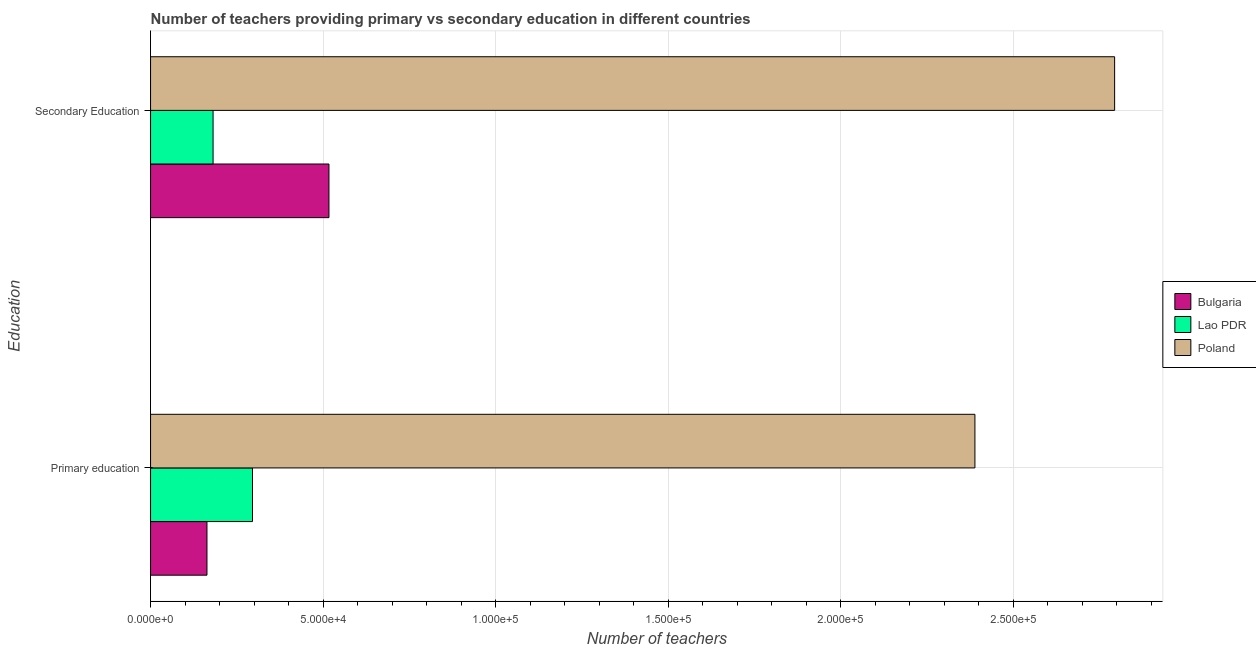Are the number of bars per tick equal to the number of legend labels?
Ensure brevity in your answer.  Yes. How many bars are there on the 2nd tick from the top?
Keep it short and to the point. 3. How many bars are there on the 2nd tick from the bottom?
Keep it short and to the point. 3. What is the label of the 1st group of bars from the top?
Give a very brief answer. Secondary Education. What is the number of primary teachers in Bulgaria?
Give a very brief answer. 1.63e+04. Across all countries, what is the maximum number of secondary teachers?
Your answer should be compact. 2.79e+05. Across all countries, what is the minimum number of primary teachers?
Keep it short and to the point. 1.63e+04. In which country was the number of secondary teachers minimum?
Ensure brevity in your answer.  Lao PDR. What is the total number of secondary teachers in the graph?
Your response must be concise. 3.49e+05. What is the difference between the number of primary teachers in Lao PDR and that in Bulgaria?
Offer a terse response. 1.32e+04. What is the difference between the number of secondary teachers in Lao PDR and the number of primary teachers in Bulgaria?
Make the answer very short. 1771. What is the average number of secondary teachers per country?
Offer a terse response. 1.16e+05. What is the difference between the number of primary teachers and number of secondary teachers in Poland?
Your answer should be very brief. -4.05e+04. What is the ratio of the number of primary teachers in Lao PDR to that in Poland?
Offer a very short reply. 0.12. Is the number of secondary teachers in Poland less than that in Bulgaria?
Your answer should be compact. No. In how many countries, is the number of primary teachers greater than the average number of primary teachers taken over all countries?
Keep it short and to the point. 1. What does the 2nd bar from the top in Primary education represents?
Offer a terse response. Lao PDR. What does the 3rd bar from the bottom in Secondary Education represents?
Offer a terse response. Poland. What is the difference between two consecutive major ticks on the X-axis?
Your response must be concise. 5.00e+04. Are the values on the major ticks of X-axis written in scientific E-notation?
Provide a short and direct response. Yes. Does the graph contain any zero values?
Ensure brevity in your answer.  No. Does the graph contain grids?
Give a very brief answer. Yes. How many legend labels are there?
Your answer should be compact. 3. What is the title of the graph?
Make the answer very short. Number of teachers providing primary vs secondary education in different countries. What is the label or title of the X-axis?
Your response must be concise. Number of teachers. What is the label or title of the Y-axis?
Your response must be concise. Education. What is the Number of teachers of Bulgaria in Primary education?
Your response must be concise. 1.63e+04. What is the Number of teachers in Lao PDR in Primary education?
Your answer should be very brief. 2.95e+04. What is the Number of teachers of Poland in Primary education?
Offer a terse response. 2.39e+05. What is the Number of teachers in Bulgaria in Secondary Education?
Keep it short and to the point. 5.17e+04. What is the Number of teachers of Lao PDR in Secondary Education?
Give a very brief answer. 1.81e+04. What is the Number of teachers of Poland in Secondary Education?
Your answer should be compact. 2.79e+05. Across all Education, what is the maximum Number of teachers of Bulgaria?
Keep it short and to the point. 5.17e+04. Across all Education, what is the maximum Number of teachers in Lao PDR?
Your answer should be very brief. 2.95e+04. Across all Education, what is the maximum Number of teachers of Poland?
Keep it short and to the point. 2.79e+05. Across all Education, what is the minimum Number of teachers in Bulgaria?
Provide a short and direct response. 1.63e+04. Across all Education, what is the minimum Number of teachers of Lao PDR?
Offer a terse response. 1.81e+04. Across all Education, what is the minimum Number of teachers in Poland?
Keep it short and to the point. 2.39e+05. What is the total Number of teachers of Bulgaria in the graph?
Your answer should be compact. 6.80e+04. What is the total Number of teachers in Lao PDR in the graph?
Offer a terse response. 4.77e+04. What is the total Number of teachers in Poland in the graph?
Offer a terse response. 5.18e+05. What is the difference between the Number of teachers in Bulgaria in Primary education and that in Secondary Education?
Provide a short and direct response. -3.54e+04. What is the difference between the Number of teachers in Lao PDR in Primary education and that in Secondary Education?
Your answer should be very brief. 1.14e+04. What is the difference between the Number of teachers of Poland in Primary education and that in Secondary Education?
Offer a terse response. -4.05e+04. What is the difference between the Number of teachers in Bulgaria in Primary education and the Number of teachers in Lao PDR in Secondary Education?
Ensure brevity in your answer.  -1771. What is the difference between the Number of teachers of Bulgaria in Primary education and the Number of teachers of Poland in Secondary Education?
Your answer should be compact. -2.63e+05. What is the difference between the Number of teachers in Lao PDR in Primary education and the Number of teachers in Poland in Secondary Education?
Offer a terse response. -2.50e+05. What is the average Number of teachers of Bulgaria per Education?
Offer a very short reply. 3.40e+04. What is the average Number of teachers of Lao PDR per Education?
Ensure brevity in your answer.  2.38e+04. What is the average Number of teachers in Poland per Education?
Give a very brief answer. 2.59e+05. What is the difference between the Number of teachers in Bulgaria and Number of teachers in Lao PDR in Primary education?
Provide a short and direct response. -1.32e+04. What is the difference between the Number of teachers of Bulgaria and Number of teachers of Poland in Primary education?
Keep it short and to the point. -2.23e+05. What is the difference between the Number of teachers of Lao PDR and Number of teachers of Poland in Primary education?
Ensure brevity in your answer.  -2.09e+05. What is the difference between the Number of teachers of Bulgaria and Number of teachers of Lao PDR in Secondary Education?
Offer a terse response. 3.36e+04. What is the difference between the Number of teachers in Bulgaria and Number of teachers in Poland in Secondary Education?
Your response must be concise. -2.28e+05. What is the difference between the Number of teachers in Lao PDR and Number of teachers in Poland in Secondary Education?
Provide a short and direct response. -2.61e+05. What is the ratio of the Number of teachers in Bulgaria in Primary education to that in Secondary Education?
Offer a terse response. 0.32. What is the ratio of the Number of teachers of Lao PDR in Primary education to that in Secondary Education?
Ensure brevity in your answer.  1.63. What is the ratio of the Number of teachers in Poland in Primary education to that in Secondary Education?
Your answer should be compact. 0.86. What is the difference between the highest and the second highest Number of teachers of Bulgaria?
Provide a succinct answer. 3.54e+04. What is the difference between the highest and the second highest Number of teachers in Lao PDR?
Ensure brevity in your answer.  1.14e+04. What is the difference between the highest and the second highest Number of teachers of Poland?
Your answer should be compact. 4.05e+04. What is the difference between the highest and the lowest Number of teachers in Bulgaria?
Your answer should be very brief. 3.54e+04. What is the difference between the highest and the lowest Number of teachers in Lao PDR?
Your answer should be compact. 1.14e+04. What is the difference between the highest and the lowest Number of teachers of Poland?
Provide a succinct answer. 4.05e+04. 